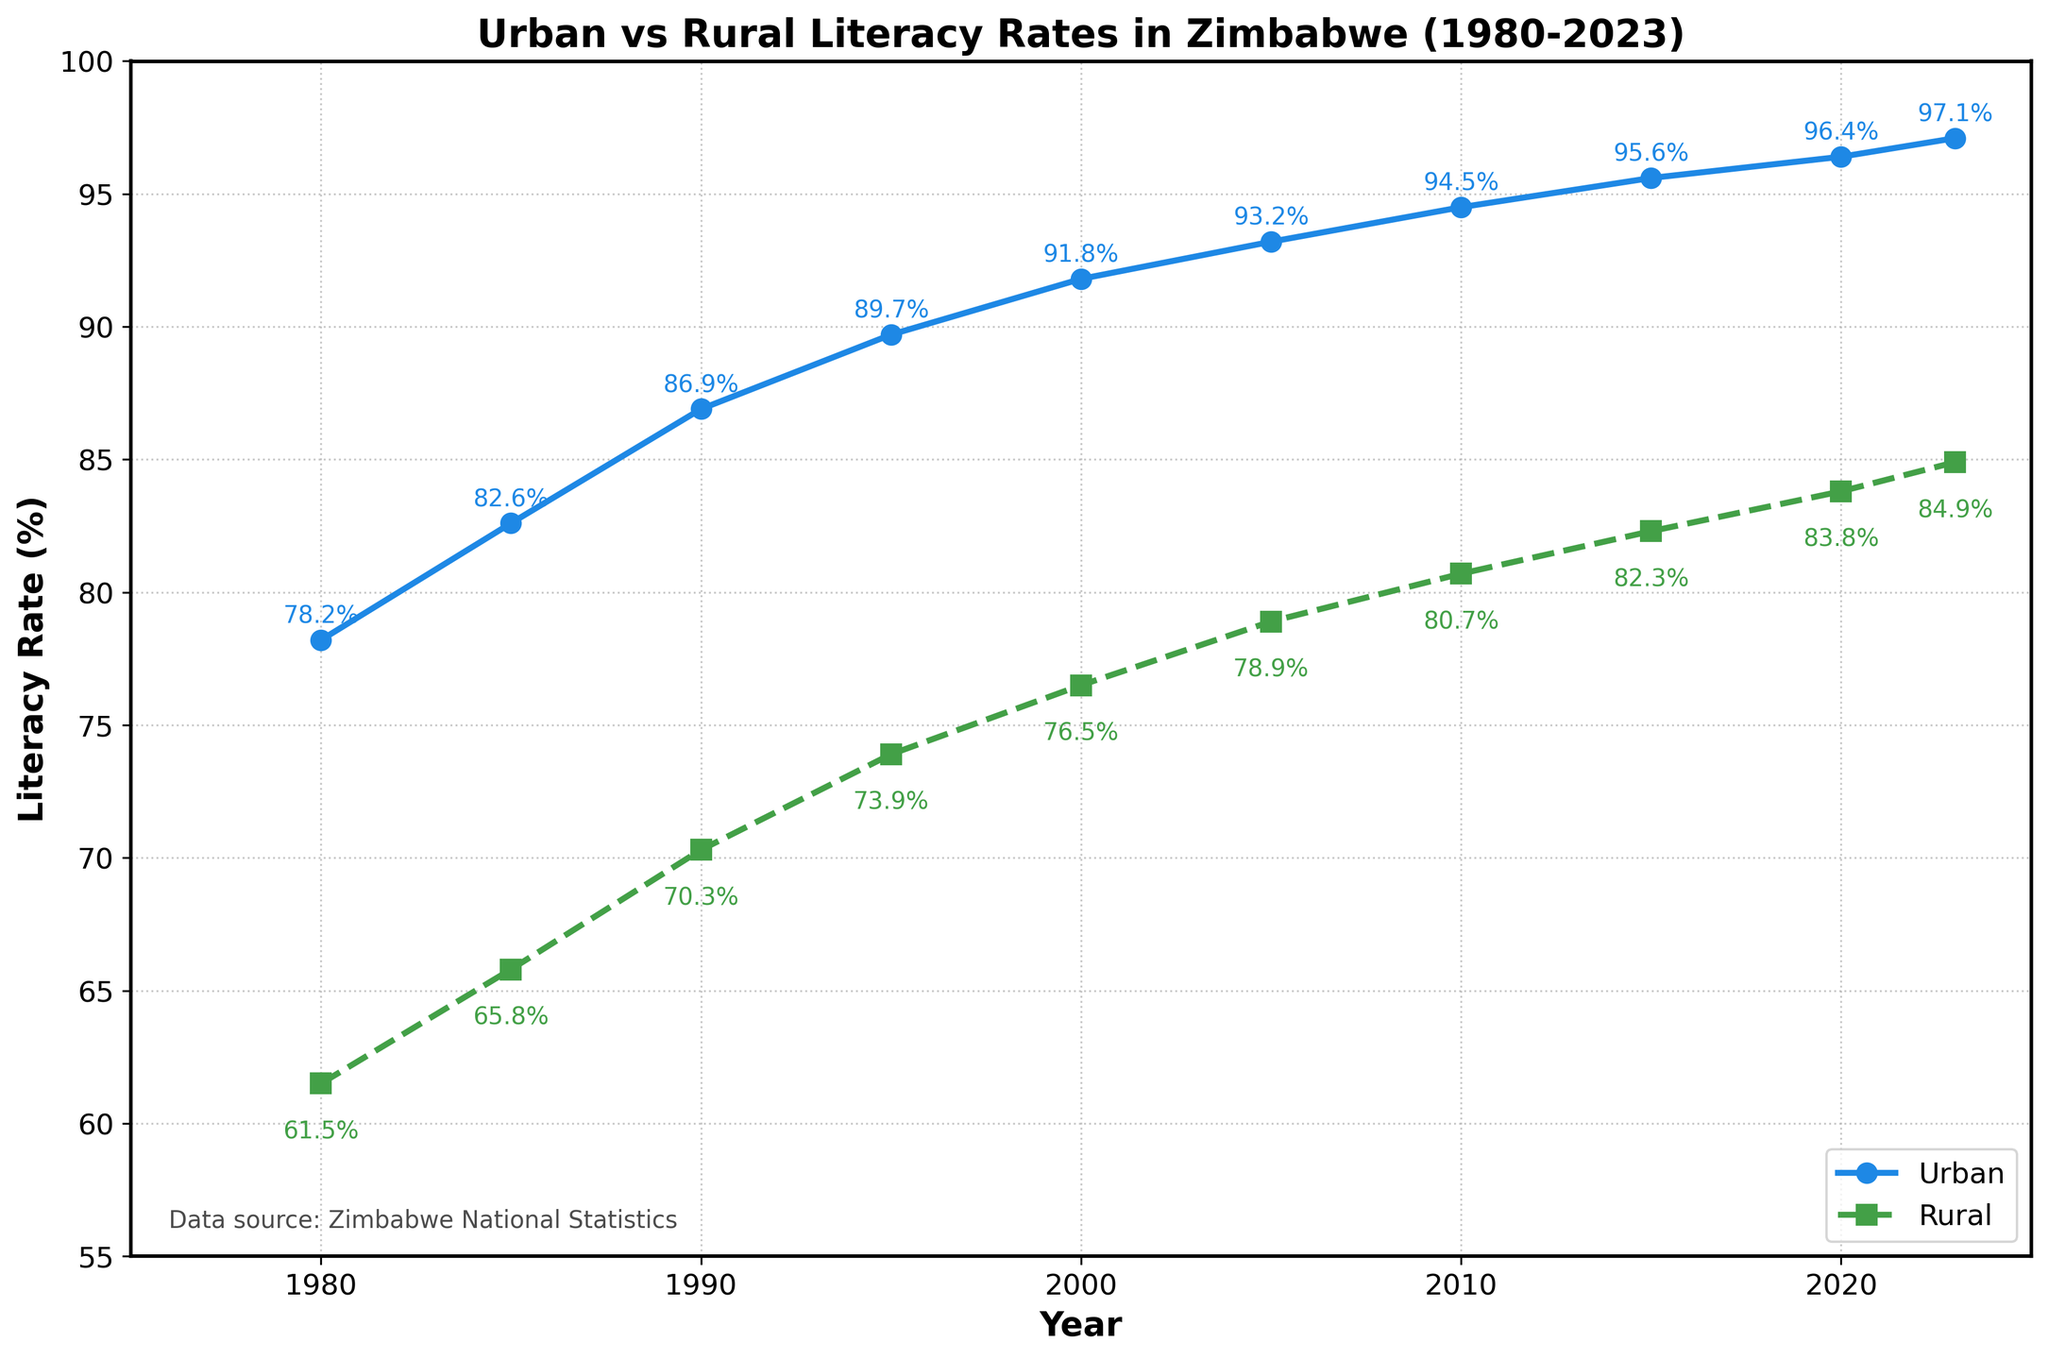What is the Literacy Rate for Urban areas in 1980? To answer this, find the urban literacy rate corresponding to the year 1980 on the chart. The rate is indicated by the blue line.
Answer: 78.2% How much did the Rural Literacy Rate increase from 1980 to 2023? To determine the increase in rural literacy rate, subtract the rate in 1980 (61.5%) from the rate in 2023 (84.9%).
Answer: 23.4% In which year did the Urban Literacy Rate surpass 90%? To find the year when the urban literacy rate first surpassed 90%, look at the blue line and identify the year when it crosses the 90% mark.
Answer: 1995 Which has a higher literacy rate in 2020, Urban or Rural areas? Compare the literacy rates in urban and rural areas for the year 2020 by looking at the chart's annotations or line positions.
Answer: Urban What is the average increase per decade in Urban Literacy Rate from 1980 to 2023? Calculate the total increase in urban literacy rate from 1980 (78.2%) to 2023 (97.1%) which is 18.9%. There are about 4.3 decades between 1980 and 2023. The average increase per decade is 18.9% / 4.3.
Answer: 4.4% What is the minimum literacy rate shown for Rural areas? Find the lowest value on the green line, which represents the rural literacy rate. The lowest value is at the start, in 1980.
Answer: 61.5% When did the gap between Urban and Rural Literacy Rates start to narrow significantly? Look at the periods where the gap between the blue and green lines begins to narrow more noticeably. This appears to start around the early 2000s.
Answer: Early 2000s What was the average Literacy Rate for Rural areas from 1980 to 2023? To find the average, sum all the rural literacy rates given and divide by the number of years (10). (61.5 + 65.8 + 70.3 + 73.9 + 76.5 + 78.9 + 80.7 + 82.3 + 83.8 + 84.9) / 10.
Answer: 75.8% How does the trend of Urban Literacy Rate compare to Rural Literacy Rate from 2000 to 2023? Examine the lines from 2000 to 2023. Both show an upward trend, but the rural literacy rate has a smaller slope compared to the urban literacy rate, indicating a slower increase.
Answer: Both increasing, Rural slower What is the difference between the Urban and Rural Literacy Rate in 1990? Subtract the rural literacy rate in 1990 (70.3%) from the urban literacy rate in 1990 (86.9%).
Answer: 16.6% 